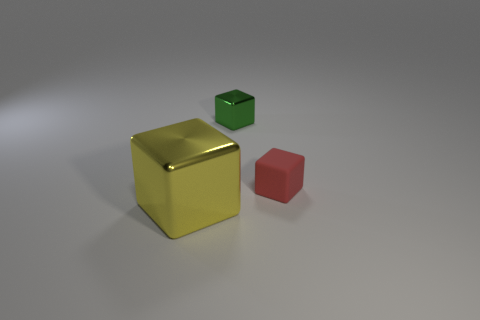Add 2 yellow metallic cubes. How many objects exist? 5 Add 2 small green metal objects. How many small green metal objects exist? 3 Subtract 0 gray cylinders. How many objects are left? 3 Subtract all big yellow cubes. Subtract all big brown shiny cubes. How many objects are left? 2 Add 1 tiny red matte cubes. How many tiny red matte cubes are left? 2 